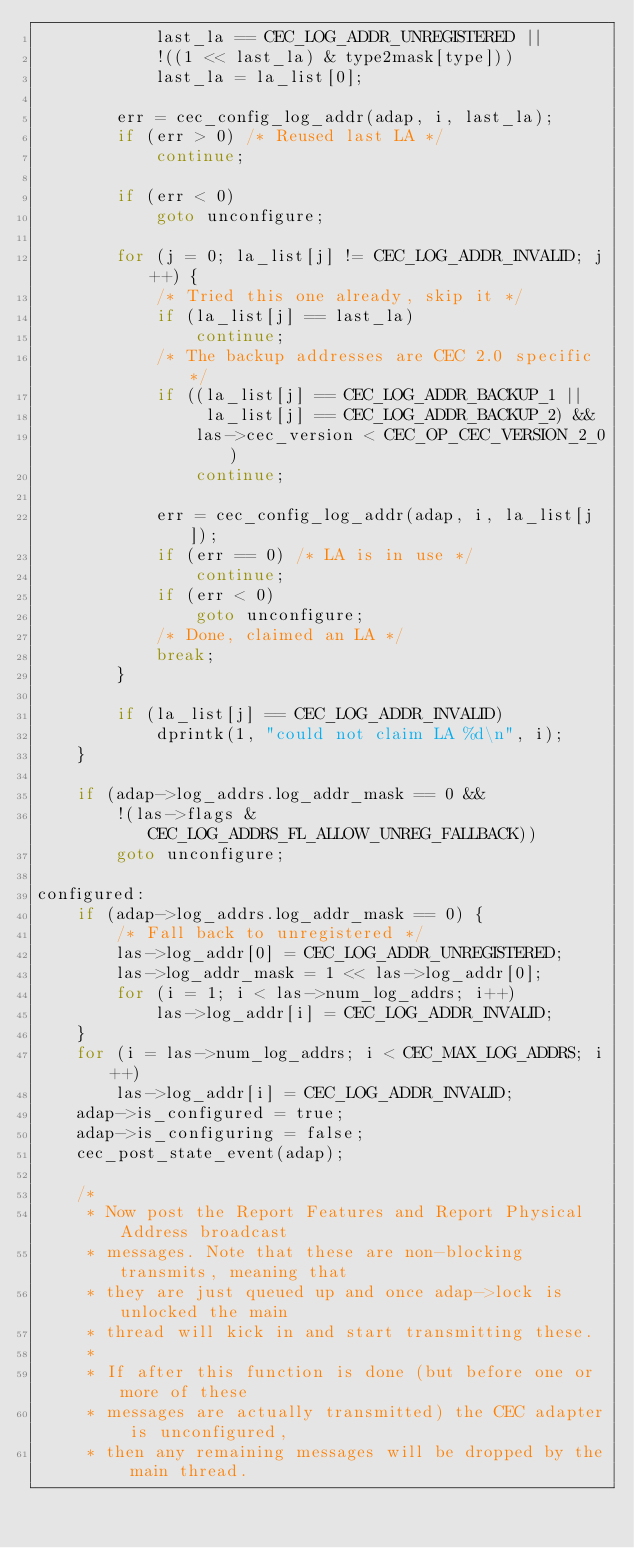Convert code to text. <code><loc_0><loc_0><loc_500><loc_500><_C_>		    last_la == CEC_LOG_ADDR_UNREGISTERED ||
		    !((1 << last_la) & type2mask[type]))
			last_la = la_list[0];

		err = cec_config_log_addr(adap, i, last_la);
		if (err > 0) /* Reused last LA */
			continue;

		if (err < 0)
			goto unconfigure;

		for (j = 0; la_list[j] != CEC_LOG_ADDR_INVALID; j++) {
			/* Tried this one already, skip it */
			if (la_list[j] == last_la)
				continue;
			/* The backup addresses are CEC 2.0 specific */
			if ((la_list[j] == CEC_LOG_ADDR_BACKUP_1 ||
			     la_list[j] == CEC_LOG_ADDR_BACKUP_2) &&
			    las->cec_version < CEC_OP_CEC_VERSION_2_0)
				continue;

			err = cec_config_log_addr(adap, i, la_list[j]);
			if (err == 0) /* LA is in use */
				continue;
			if (err < 0)
				goto unconfigure;
			/* Done, claimed an LA */
			break;
		}

		if (la_list[j] == CEC_LOG_ADDR_INVALID)
			dprintk(1, "could not claim LA %d\n", i);
	}

	if (adap->log_addrs.log_addr_mask == 0 &&
	    !(las->flags & CEC_LOG_ADDRS_FL_ALLOW_UNREG_FALLBACK))
		goto unconfigure;

configured:
	if (adap->log_addrs.log_addr_mask == 0) {
		/* Fall back to unregistered */
		las->log_addr[0] = CEC_LOG_ADDR_UNREGISTERED;
		las->log_addr_mask = 1 << las->log_addr[0];
		for (i = 1; i < las->num_log_addrs; i++)
			las->log_addr[i] = CEC_LOG_ADDR_INVALID;
	}
	for (i = las->num_log_addrs; i < CEC_MAX_LOG_ADDRS; i++)
		las->log_addr[i] = CEC_LOG_ADDR_INVALID;
	adap->is_configured = true;
	adap->is_configuring = false;
	cec_post_state_event(adap);

	/*
	 * Now post the Report Features and Report Physical Address broadcast
	 * messages. Note that these are non-blocking transmits, meaning that
	 * they are just queued up and once adap->lock is unlocked the main
	 * thread will kick in and start transmitting these.
	 *
	 * If after this function is done (but before one or more of these
	 * messages are actually transmitted) the CEC adapter is unconfigured,
	 * then any remaining messages will be dropped by the main thread.</code> 